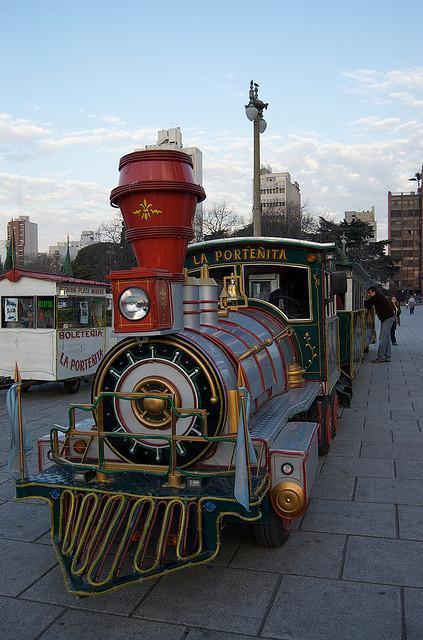How many black dogs are there?
Give a very brief answer. 0. 